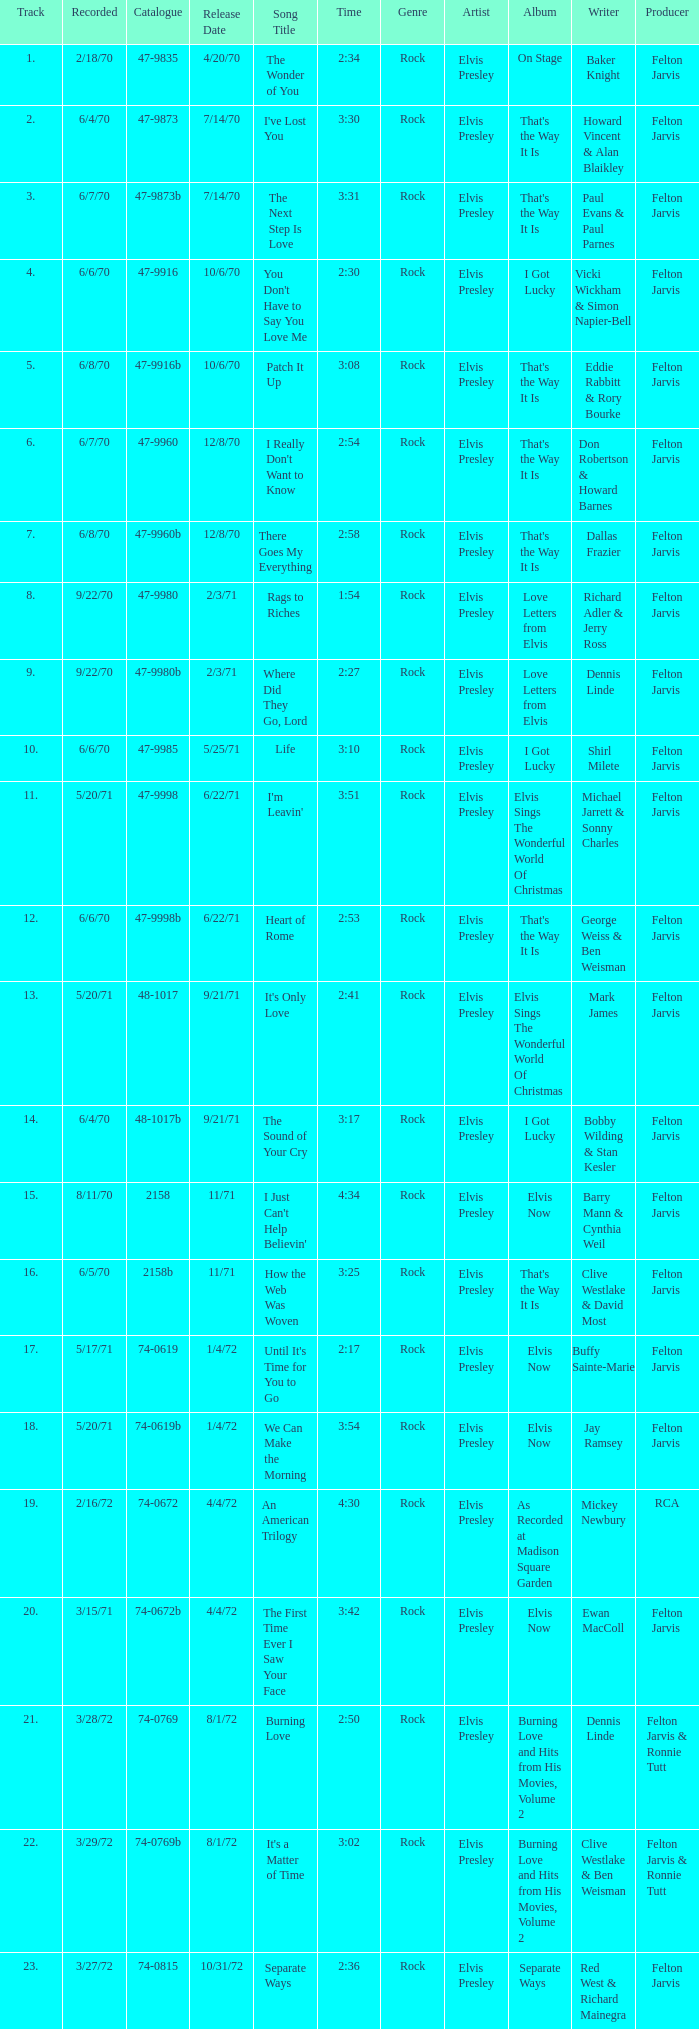What is the catalogue number for the song that is 3:17 and was released 9/21/71? 48-1017b. 